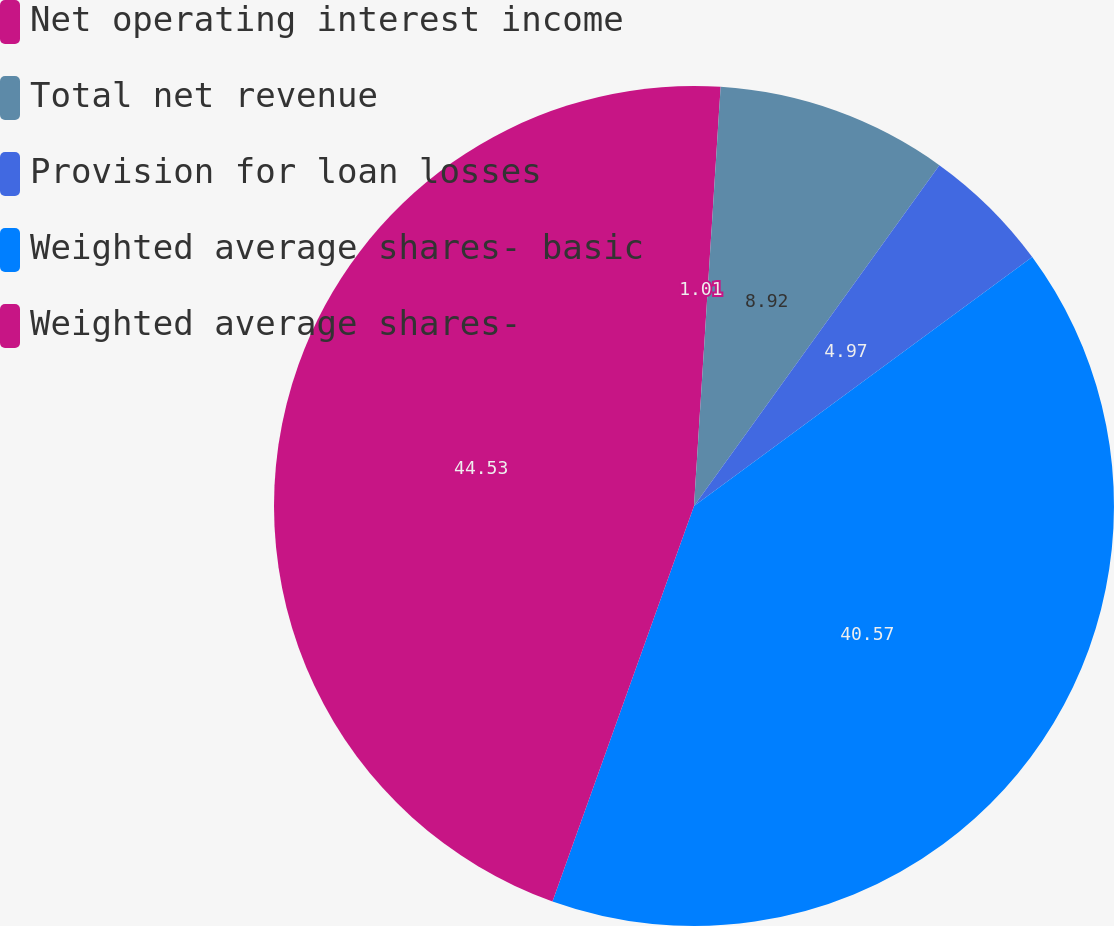<chart> <loc_0><loc_0><loc_500><loc_500><pie_chart><fcel>Net operating interest income<fcel>Total net revenue<fcel>Provision for loan losses<fcel>Weighted average shares- basic<fcel>Weighted average shares-<nl><fcel>1.01%<fcel>8.92%<fcel>4.97%<fcel>40.57%<fcel>44.53%<nl></chart> 